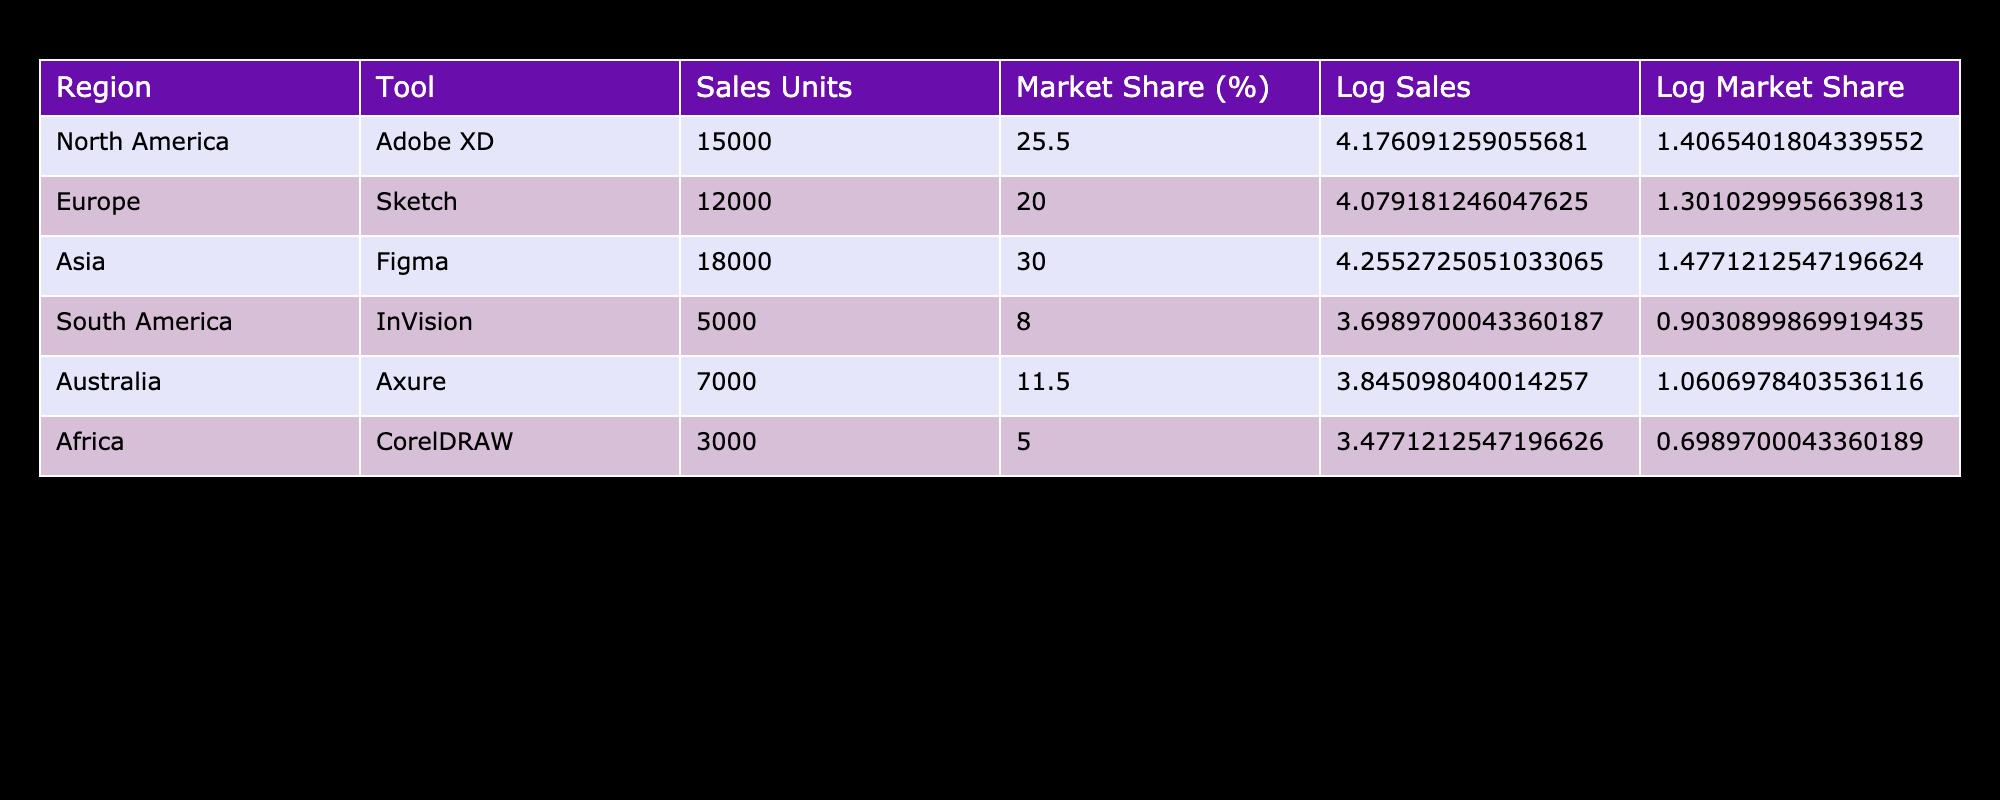What is the total number of Sales Units for all regions? To find the total number of Sales Units, I need to sum the Sales Units for all regions listed in the table: 15000 (North America) + 12000 (Europe) + 18000 (Asia) + 5000 (South America) + 7000 (Australia) + 3000 (Africa) = 60000
Answer: 60000 Which region has the highest Market Share Percentage? By looking at the Market Share Percentage column, I see that Asia (30.0) has the highest value compared to other regions: 25.5 (North America), 20.0 (Europe), 8.0 (South America), 11.5 (Australia), and 5.0 (Africa)
Answer: Asia Is the Market Share Percentage for Figma greater than 25%? Figma's Market Share Percentage is 30.0, which is greater than 25%. Thus, the statement is true
Answer: Yes What are the Log Sales Units for Adobe XD? The Log Sales Units for Adobe XD is calculated using the Logarithm value based on its Sales Units. The Sales Units are 15000, and the Logarithm (base 10) of 15000 is approximately 4.176. Therefore, the Log Sales Units is 4.176
Answer: 4.176 What is the average Market Share Percentage across all regions? To find the average, I need to sum all Market Share Percentages and then divide by the number of regions. The sum is 25.5 + 20 + 30 + 8 + 11.5 + 5 = 100. The number of regions is 6, hence the average is 100 / 6 = 16.67
Answer: 16.67 Which design tool sold the least number of units? Looking through the Sales Units column, InVision has the lowest value of 5000 units sold, compared to the others: 15000 (Adobe XD), 12000 (Sketch), 18000 (Figma), 7000 (Axure), and 3000 (CorelDRAW)
Answer: InVision Is it true that the Sales Units for CorelDRAW are less than those for Axure? Comparing the Sales Units, CorelDRAW has 3000 units and Axure has 7000 units. Since 3000 is indeed less than 7000, this statement is true
Answer: Yes What is the difference in Sales Units between the top-selling tool and the bottom-selling tool? The top-selling tool is Figma with 18000 units and the bottom-selling tool is InVision with 5000 units. The difference is 18000 - 5000 = 13000 units
Answer: 13000 